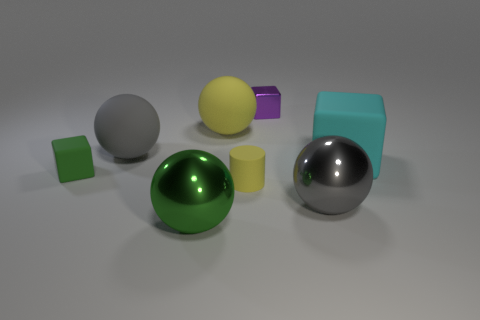Subtract all small blocks. How many blocks are left? 1 Add 2 tiny balls. How many objects exist? 10 Subtract all green spheres. How many spheres are left? 3 Subtract 1 spheres. How many spheres are left? 3 Subtract all cylinders. How many objects are left? 7 Subtract all brown cylinders. How many gray spheres are left? 2 Subtract 0 brown blocks. How many objects are left? 8 Subtract all yellow blocks. Subtract all purple cylinders. How many blocks are left? 3 Subtract all large yellow metallic things. Subtract all rubber cylinders. How many objects are left? 7 Add 6 rubber spheres. How many rubber spheres are left? 8 